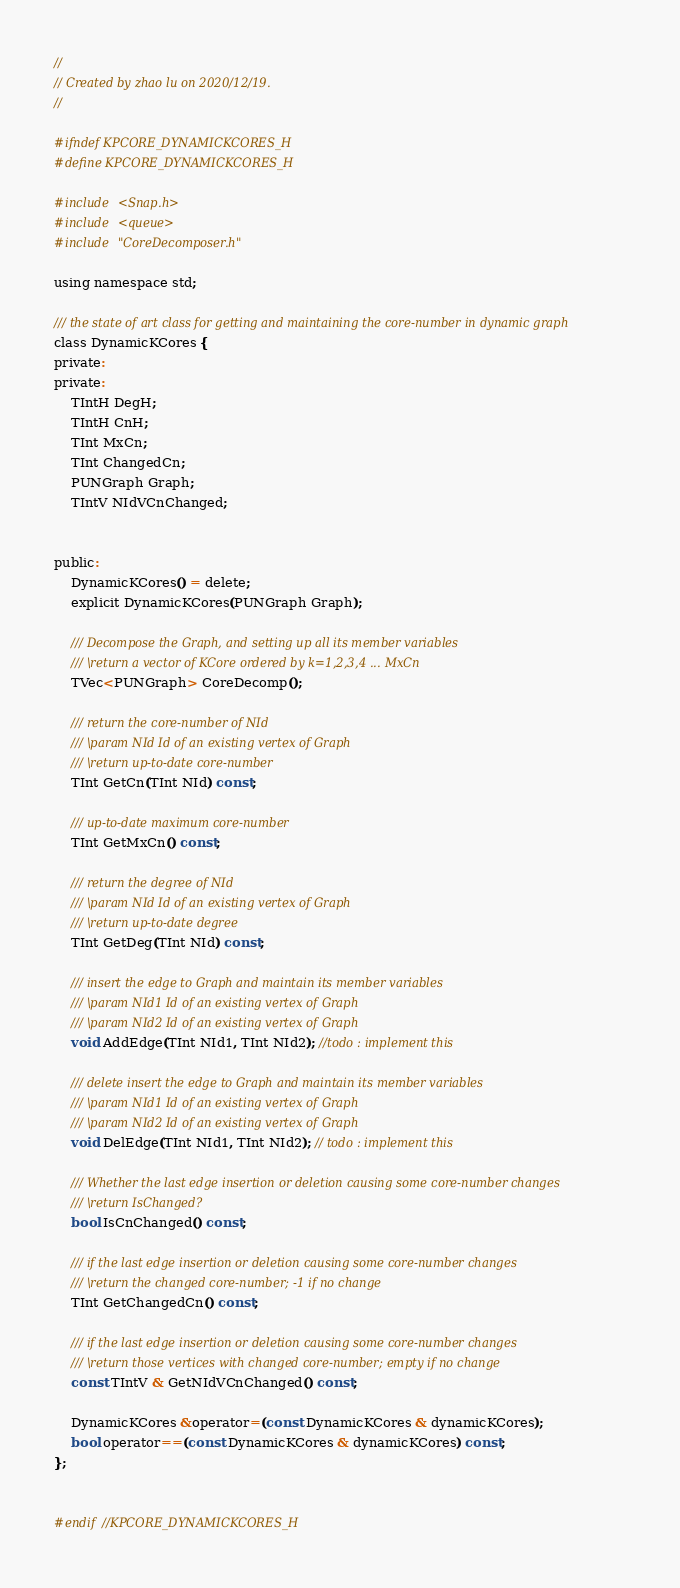<code> <loc_0><loc_0><loc_500><loc_500><_C_>//
// Created by zhao lu on 2020/12/19.
//

#ifndef KPCORE_DYNAMICKCORES_H
#define KPCORE_DYNAMICKCORES_H

#include <Snap.h>
#include <queue>
#include "CoreDecomposer.h"

using namespace std;

/// the state of art class for getting and maintaining the core-number in dynamic graph
class DynamicKCores {
private:
private:
    TIntH DegH;
    TIntH CnH;
    TInt MxCn;
    TInt ChangedCn;
    PUNGraph Graph;
    TIntV NIdVCnChanged;


public:
    DynamicKCores() = delete;
    explicit DynamicKCores(PUNGraph Graph);

    /// Decompose the Graph, and setting up all its member variables
    /// \return a vector of KCore ordered by k=1,2,3,4 ... MxCn
    TVec<PUNGraph> CoreDecomp();

    /// return the core-number of NId
    /// \param NId Id of an existing vertex of Graph
    /// \return up-to-date core-number
    TInt GetCn(TInt NId) const;

    /// up-to-date maximum core-number
    TInt GetMxCn() const;

    /// return the degree of NId
    /// \param NId Id of an existing vertex of Graph
    /// \return up-to-date degree
    TInt GetDeg(TInt NId) const;

    /// insert the edge to Graph and maintain its member variables
    /// \param NId1 Id of an existing vertex of Graph
    /// \param NId2 Id of an existing vertex of Graph
    void AddEdge(TInt NId1, TInt NId2); //todo : implement this

    /// delete insert the edge to Graph and maintain its member variables
    /// \param NId1 Id of an existing vertex of Graph
    /// \param NId2 Id of an existing vertex of Graph
    void DelEdge(TInt NId1, TInt NId2); // todo : implement this

    /// Whether the last edge insertion or deletion causing some core-number changes
    /// \return IsChanged?
    bool IsCnChanged() const;

    /// if the last edge insertion or deletion causing some core-number changes
    /// \return the changed core-number; -1 if no change
    TInt GetChangedCn() const;

    /// if the last edge insertion or deletion causing some core-number changes
    /// \return those vertices with changed core-number; empty if no change
    const TIntV & GetNIdVCnChanged() const;

    DynamicKCores &operator=(const DynamicKCores & dynamicKCores);
    bool operator==(const DynamicKCores & dynamicKCores) const;
};


#endif //KPCORE_DYNAMICKCORES_H
</code> 